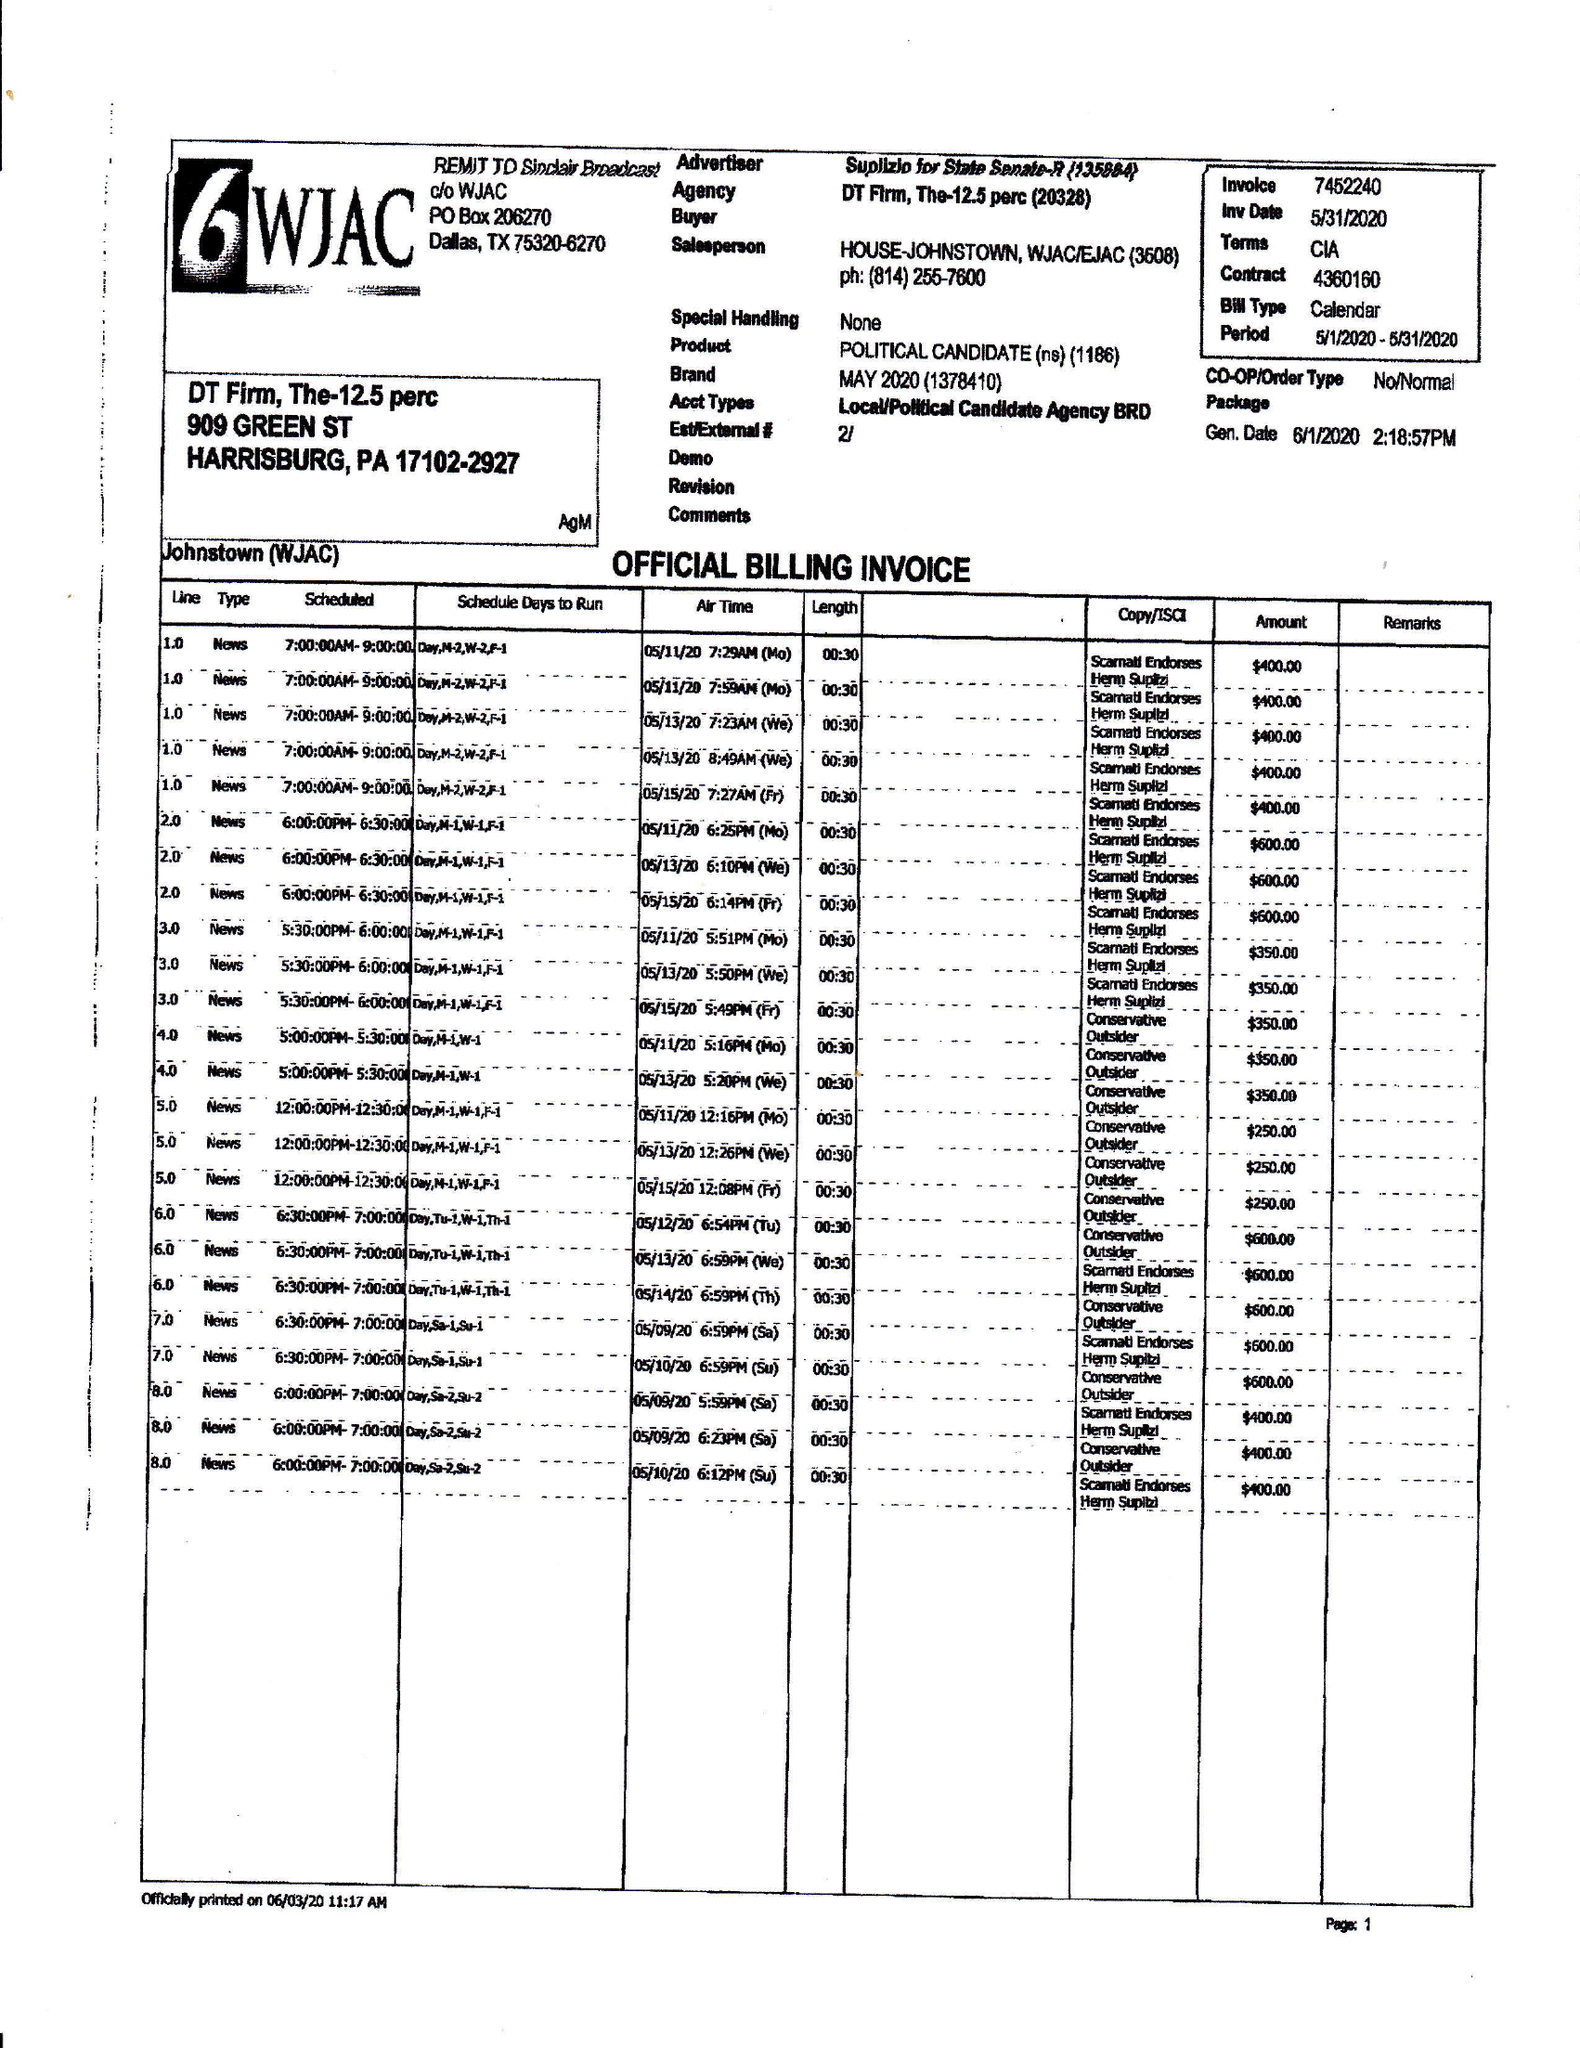What is the value for the flight_from?
Answer the question using a single word or phrase. 05/01/20 